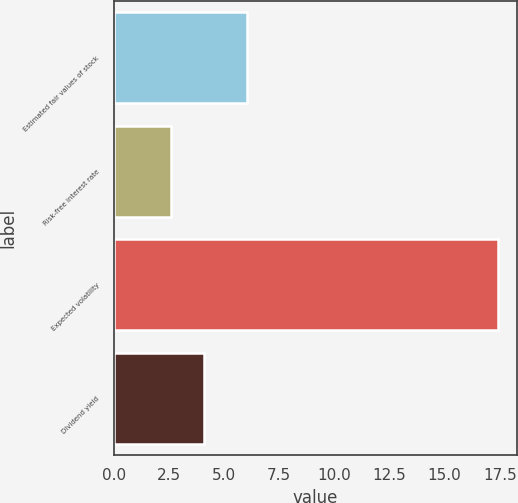Convert chart to OTSL. <chart><loc_0><loc_0><loc_500><loc_500><bar_chart><fcel>Estimated fair values of stock<fcel>Risk-free interest rate<fcel>Expected volatility<fcel>Dividend yield<nl><fcel>6.03<fcel>2.6<fcel>17.4<fcel>4.08<nl></chart> 